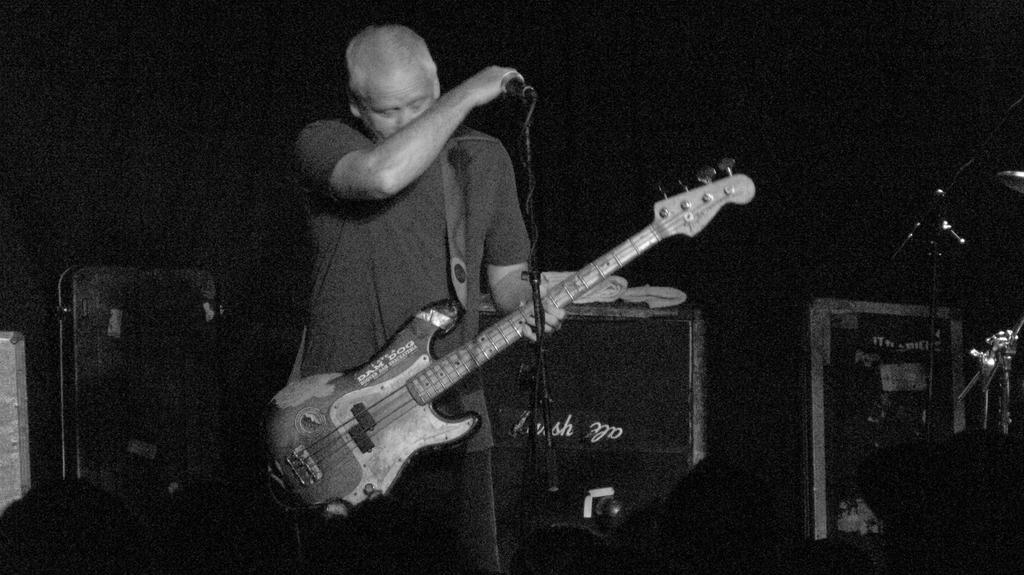Who is the main subject in the image? There is a man in the image. What is the man holding in the image? The man is holding a guitar. What is in front of the man that might be used for amplifying his voice? There is a microphone in front of the man. What is supporting the microphone in the image? There is a microphone stand in front of the man. What can be seen in the background of the image? There are other items visible in the background of the image. What type of muscle is being exercised by the man in the image? There is no indication in the image that the man is exercising any muscles; he is holding a guitar and standing near a microphone. 